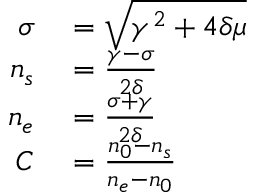<formula> <loc_0><loc_0><loc_500><loc_500>\begin{array} { r l } { \sigma } & = \sqrt { \gamma ^ { 2 } + 4 \delta \mu } } \\ { n _ { s } } & = \frac { \gamma - \sigma } { 2 \delta } } \\ { n _ { e } } & = \frac { \sigma + \gamma } { 2 \delta } } \\ { C } & = \frac { n _ { 0 } - n _ { s } } { n _ { e } - n _ { 0 } } } \end{array}</formula> 